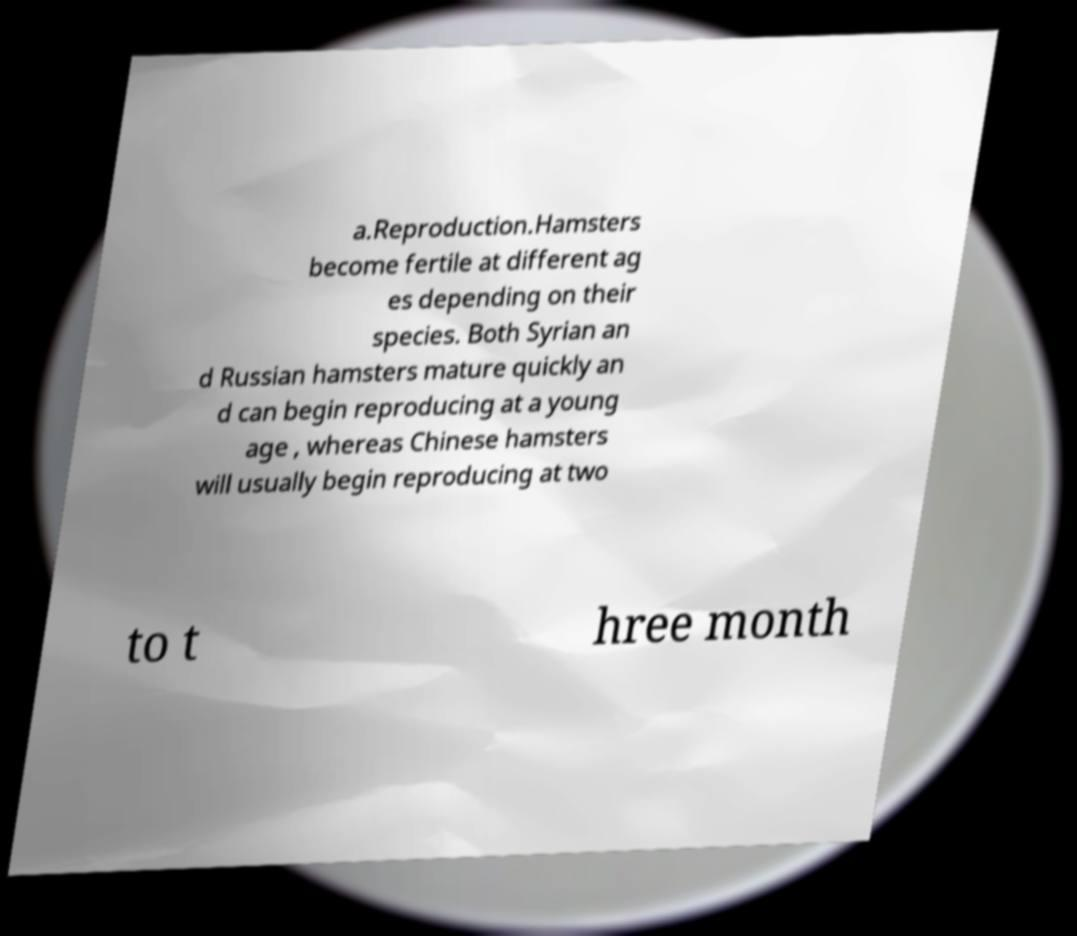Can you accurately transcribe the text from the provided image for me? a.Reproduction.Hamsters become fertile at different ag es depending on their species. Both Syrian an d Russian hamsters mature quickly an d can begin reproducing at a young age , whereas Chinese hamsters will usually begin reproducing at two to t hree month 